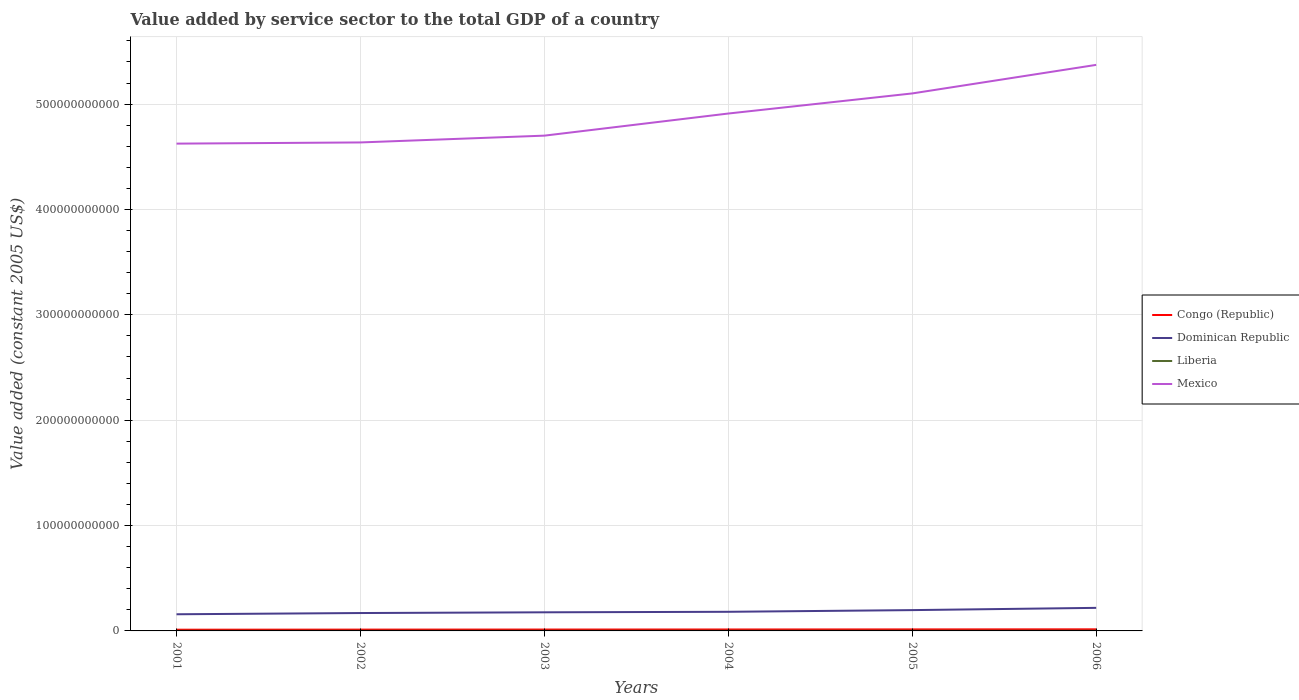Is the number of lines equal to the number of legend labels?
Offer a very short reply. Yes. Across all years, what is the maximum value added by service sector in Mexico?
Ensure brevity in your answer.  4.62e+11. In which year was the value added by service sector in Mexico maximum?
Give a very brief answer. 2001. What is the total value added by service sector in Liberia in the graph?
Your answer should be compact. -7.32e+06. What is the difference between the highest and the second highest value added by service sector in Mexico?
Ensure brevity in your answer.  7.47e+1. What is the difference between the highest and the lowest value added by service sector in Congo (Republic)?
Ensure brevity in your answer.  3. Is the value added by service sector in Congo (Republic) strictly greater than the value added by service sector in Mexico over the years?
Your answer should be compact. Yes. How many lines are there?
Keep it short and to the point. 4. What is the difference between two consecutive major ticks on the Y-axis?
Your response must be concise. 1.00e+11. Does the graph contain any zero values?
Offer a terse response. No. Does the graph contain grids?
Keep it short and to the point. Yes. Where does the legend appear in the graph?
Ensure brevity in your answer.  Center right. How many legend labels are there?
Provide a short and direct response. 4. How are the legend labels stacked?
Your answer should be compact. Vertical. What is the title of the graph?
Ensure brevity in your answer.  Value added by service sector to the total GDP of a country. What is the label or title of the X-axis?
Make the answer very short. Years. What is the label or title of the Y-axis?
Ensure brevity in your answer.  Value added (constant 2005 US$). What is the Value added (constant 2005 US$) of Congo (Republic) in 2001?
Make the answer very short. 1.16e+09. What is the Value added (constant 2005 US$) in Dominican Republic in 2001?
Give a very brief answer. 1.58e+1. What is the Value added (constant 2005 US$) in Liberia in 2001?
Your answer should be very brief. 1.06e+08. What is the Value added (constant 2005 US$) of Mexico in 2001?
Offer a terse response. 4.62e+11. What is the Value added (constant 2005 US$) of Congo (Republic) in 2002?
Keep it short and to the point. 1.25e+09. What is the Value added (constant 2005 US$) of Dominican Republic in 2002?
Ensure brevity in your answer.  1.70e+1. What is the Value added (constant 2005 US$) in Liberia in 2002?
Make the answer very short. 1.13e+08. What is the Value added (constant 2005 US$) of Mexico in 2002?
Ensure brevity in your answer.  4.64e+11. What is the Value added (constant 2005 US$) of Congo (Republic) in 2003?
Ensure brevity in your answer.  1.31e+09. What is the Value added (constant 2005 US$) of Dominican Republic in 2003?
Keep it short and to the point. 1.77e+1. What is the Value added (constant 2005 US$) in Liberia in 2003?
Your answer should be very brief. 1.11e+08. What is the Value added (constant 2005 US$) of Mexico in 2003?
Your answer should be compact. 4.70e+11. What is the Value added (constant 2005 US$) of Congo (Republic) in 2004?
Provide a short and direct response. 1.37e+09. What is the Value added (constant 2005 US$) in Dominican Republic in 2004?
Your answer should be compact. 1.81e+1. What is the Value added (constant 2005 US$) in Liberia in 2004?
Give a very brief answer. 1.35e+08. What is the Value added (constant 2005 US$) in Mexico in 2004?
Give a very brief answer. 4.91e+11. What is the Value added (constant 2005 US$) in Congo (Republic) in 2005?
Provide a short and direct response. 1.43e+09. What is the Value added (constant 2005 US$) in Dominican Republic in 2005?
Ensure brevity in your answer.  1.97e+1. What is the Value added (constant 2005 US$) in Liberia in 2005?
Your answer should be very brief. 1.47e+08. What is the Value added (constant 2005 US$) of Mexico in 2005?
Your answer should be compact. 5.10e+11. What is the Value added (constant 2005 US$) in Congo (Republic) in 2006?
Provide a short and direct response. 1.51e+09. What is the Value added (constant 2005 US$) in Dominican Republic in 2006?
Offer a very short reply. 2.19e+1. What is the Value added (constant 2005 US$) in Liberia in 2006?
Offer a terse response. 1.67e+08. What is the Value added (constant 2005 US$) in Mexico in 2006?
Make the answer very short. 5.37e+11. Across all years, what is the maximum Value added (constant 2005 US$) in Congo (Republic)?
Keep it short and to the point. 1.51e+09. Across all years, what is the maximum Value added (constant 2005 US$) of Dominican Republic?
Give a very brief answer. 2.19e+1. Across all years, what is the maximum Value added (constant 2005 US$) of Liberia?
Offer a very short reply. 1.67e+08. Across all years, what is the maximum Value added (constant 2005 US$) in Mexico?
Give a very brief answer. 5.37e+11. Across all years, what is the minimum Value added (constant 2005 US$) of Congo (Republic)?
Offer a terse response. 1.16e+09. Across all years, what is the minimum Value added (constant 2005 US$) of Dominican Republic?
Keep it short and to the point. 1.58e+1. Across all years, what is the minimum Value added (constant 2005 US$) of Liberia?
Make the answer very short. 1.06e+08. Across all years, what is the minimum Value added (constant 2005 US$) of Mexico?
Your response must be concise. 4.62e+11. What is the total Value added (constant 2005 US$) of Congo (Republic) in the graph?
Provide a short and direct response. 8.03e+09. What is the total Value added (constant 2005 US$) in Dominican Republic in the graph?
Ensure brevity in your answer.  1.10e+11. What is the total Value added (constant 2005 US$) in Liberia in the graph?
Your response must be concise. 7.80e+08. What is the total Value added (constant 2005 US$) in Mexico in the graph?
Keep it short and to the point. 2.93e+12. What is the difference between the Value added (constant 2005 US$) of Congo (Republic) in 2001 and that in 2002?
Provide a succinct answer. -8.60e+07. What is the difference between the Value added (constant 2005 US$) of Dominican Republic in 2001 and that in 2002?
Your answer should be very brief. -1.18e+09. What is the difference between the Value added (constant 2005 US$) of Liberia in 2001 and that in 2002?
Make the answer very short. -7.32e+06. What is the difference between the Value added (constant 2005 US$) in Mexico in 2001 and that in 2002?
Your response must be concise. -1.12e+09. What is the difference between the Value added (constant 2005 US$) in Congo (Republic) in 2001 and that in 2003?
Give a very brief answer. -1.43e+08. What is the difference between the Value added (constant 2005 US$) in Dominican Republic in 2001 and that in 2003?
Your answer should be very brief. -1.86e+09. What is the difference between the Value added (constant 2005 US$) of Liberia in 2001 and that in 2003?
Your response must be concise. -5.58e+06. What is the difference between the Value added (constant 2005 US$) of Mexico in 2001 and that in 2003?
Offer a terse response. -7.57e+09. What is the difference between the Value added (constant 2005 US$) of Congo (Republic) in 2001 and that in 2004?
Give a very brief answer. -2.03e+08. What is the difference between the Value added (constant 2005 US$) of Dominican Republic in 2001 and that in 2004?
Provide a succinct answer. -2.34e+09. What is the difference between the Value added (constant 2005 US$) of Liberia in 2001 and that in 2004?
Provide a succinct answer. -2.94e+07. What is the difference between the Value added (constant 2005 US$) of Mexico in 2001 and that in 2004?
Give a very brief answer. -2.86e+1. What is the difference between the Value added (constant 2005 US$) in Congo (Republic) in 2001 and that in 2005?
Give a very brief answer. -2.72e+08. What is the difference between the Value added (constant 2005 US$) of Dominican Republic in 2001 and that in 2005?
Make the answer very short. -3.94e+09. What is the difference between the Value added (constant 2005 US$) of Liberia in 2001 and that in 2005?
Your answer should be compact. -4.12e+07. What is the difference between the Value added (constant 2005 US$) in Mexico in 2001 and that in 2005?
Your answer should be compact. -4.76e+1. What is the difference between the Value added (constant 2005 US$) of Congo (Republic) in 2001 and that in 2006?
Ensure brevity in your answer.  -3.52e+08. What is the difference between the Value added (constant 2005 US$) of Dominican Republic in 2001 and that in 2006?
Offer a very short reply. -6.09e+09. What is the difference between the Value added (constant 2005 US$) in Liberia in 2001 and that in 2006?
Give a very brief answer. -6.15e+07. What is the difference between the Value added (constant 2005 US$) of Mexico in 2001 and that in 2006?
Keep it short and to the point. -7.47e+1. What is the difference between the Value added (constant 2005 US$) in Congo (Republic) in 2002 and that in 2003?
Provide a succinct answer. -5.72e+07. What is the difference between the Value added (constant 2005 US$) of Dominican Republic in 2002 and that in 2003?
Provide a succinct answer. -6.85e+08. What is the difference between the Value added (constant 2005 US$) of Liberia in 2002 and that in 2003?
Offer a terse response. 1.74e+06. What is the difference between the Value added (constant 2005 US$) in Mexico in 2002 and that in 2003?
Your answer should be compact. -6.45e+09. What is the difference between the Value added (constant 2005 US$) in Congo (Republic) in 2002 and that in 2004?
Keep it short and to the point. -1.17e+08. What is the difference between the Value added (constant 2005 US$) of Dominican Republic in 2002 and that in 2004?
Keep it short and to the point. -1.16e+09. What is the difference between the Value added (constant 2005 US$) in Liberia in 2002 and that in 2004?
Your response must be concise. -2.21e+07. What is the difference between the Value added (constant 2005 US$) in Mexico in 2002 and that in 2004?
Give a very brief answer. -2.74e+1. What is the difference between the Value added (constant 2005 US$) of Congo (Republic) in 2002 and that in 2005?
Offer a very short reply. -1.86e+08. What is the difference between the Value added (constant 2005 US$) of Dominican Republic in 2002 and that in 2005?
Give a very brief answer. -2.76e+09. What is the difference between the Value added (constant 2005 US$) in Liberia in 2002 and that in 2005?
Your answer should be compact. -3.39e+07. What is the difference between the Value added (constant 2005 US$) of Mexico in 2002 and that in 2005?
Offer a very short reply. -4.65e+1. What is the difference between the Value added (constant 2005 US$) in Congo (Republic) in 2002 and that in 2006?
Your answer should be very brief. -2.66e+08. What is the difference between the Value added (constant 2005 US$) of Dominican Republic in 2002 and that in 2006?
Your answer should be very brief. -4.91e+09. What is the difference between the Value added (constant 2005 US$) of Liberia in 2002 and that in 2006?
Give a very brief answer. -5.41e+07. What is the difference between the Value added (constant 2005 US$) in Mexico in 2002 and that in 2006?
Your answer should be compact. -7.36e+1. What is the difference between the Value added (constant 2005 US$) of Congo (Republic) in 2003 and that in 2004?
Make the answer very short. -6.02e+07. What is the difference between the Value added (constant 2005 US$) of Dominican Republic in 2003 and that in 2004?
Ensure brevity in your answer.  -4.76e+08. What is the difference between the Value added (constant 2005 US$) of Liberia in 2003 and that in 2004?
Your response must be concise. -2.39e+07. What is the difference between the Value added (constant 2005 US$) in Mexico in 2003 and that in 2004?
Offer a very short reply. -2.10e+1. What is the difference between the Value added (constant 2005 US$) of Congo (Republic) in 2003 and that in 2005?
Provide a short and direct response. -1.29e+08. What is the difference between the Value added (constant 2005 US$) in Dominican Republic in 2003 and that in 2005?
Give a very brief answer. -2.08e+09. What is the difference between the Value added (constant 2005 US$) in Liberia in 2003 and that in 2005?
Offer a very short reply. -3.57e+07. What is the difference between the Value added (constant 2005 US$) in Mexico in 2003 and that in 2005?
Offer a very short reply. -4.01e+1. What is the difference between the Value added (constant 2005 US$) of Congo (Republic) in 2003 and that in 2006?
Keep it short and to the point. -2.09e+08. What is the difference between the Value added (constant 2005 US$) of Dominican Republic in 2003 and that in 2006?
Offer a terse response. -4.22e+09. What is the difference between the Value added (constant 2005 US$) in Liberia in 2003 and that in 2006?
Your answer should be compact. -5.59e+07. What is the difference between the Value added (constant 2005 US$) of Mexico in 2003 and that in 2006?
Provide a succinct answer. -6.72e+1. What is the difference between the Value added (constant 2005 US$) of Congo (Republic) in 2004 and that in 2005?
Give a very brief answer. -6.90e+07. What is the difference between the Value added (constant 2005 US$) in Dominican Republic in 2004 and that in 2005?
Offer a terse response. -1.60e+09. What is the difference between the Value added (constant 2005 US$) in Liberia in 2004 and that in 2005?
Ensure brevity in your answer.  -1.18e+07. What is the difference between the Value added (constant 2005 US$) of Mexico in 2004 and that in 2005?
Give a very brief answer. -1.91e+1. What is the difference between the Value added (constant 2005 US$) of Congo (Republic) in 2004 and that in 2006?
Offer a terse response. -1.49e+08. What is the difference between the Value added (constant 2005 US$) in Dominican Republic in 2004 and that in 2006?
Make the answer very short. -3.75e+09. What is the difference between the Value added (constant 2005 US$) of Liberia in 2004 and that in 2006?
Keep it short and to the point. -3.20e+07. What is the difference between the Value added (constant 2005 US$) in Mexico in 2004 and that in 2006?
Your response must be concise. -4.62e+1. What is the difference between the Value added (constant 2005 US$) of Congo (Republic) in 2005 and that in 2006?
Ensure brevity in your answer.  -7.96e+07. What is the difference between the Value added (constant 2005 US$) of Dominican Republic in 2005 and that in 2006?
Ensure brevity in your answer.  -2.14e+09. What is the difference between the Value added (constant 2005 US$) of Liberia in 2005 and that in 2006?
Provide a succinct answer. -2.02e+07. What is the difference between the Value added (constant 2005 US$) of Mexico in 2005 and that in 2006?
Your answer should be compact. -2.71e+1. What is the difference between the Value added (constant 2005 US$) of Congo (Republic) in 2001 and the Value added (constant 2005 US$) of Dominican Republic in 2002?
Provide a succinct answer. -1.58e+1. What is the difference between the Value added (constant 2005 US$) in Congo (Republic) in 2001 and the Value added (constant 2005 US$) in Liberia in 2002?
Your answer should be compact. 1.05e+09. What is the difference between the Value added (constant 2005 US$) in Congo (Republic) in 2001 and the Value added (constant 2005 US$) in Mexico in 2002?
Offer a terse response. -4.62e+11. What is the difference between the Value added (constant 2005 US$) in Dominican Republic in 2001 and the Value added (constant 2005 US$) in Liberia in 2002?
Offer a very short reply. 1.57e+1. What is the difference between the Value added (constant 2005 US$) of Dominican Republic in 2001 and the Value added (constant 2005 US$) of Mexico in 2002?
Your answer should be very brief. -4.48e+11. What is the difference between the Value added (constant 2005 US$) of Liberia in 2001 and the Value added (constant 2005 US$) of Mexico in 2002?
Provide a short and direct response. -4.63e+11. What is the difference between the Value added (constant 2005 US$) of Congo (Republic) in 2001 and the Value added (constant 2005 US$) of Dominican Republic in 2003?
Your answer should be compact. -1.65e+1. What is the difference between the Value added (constant 2005 US$) of Congo (Republic) in 2001 and the Value added (constant 2005 US$) of Liberia in 2003?
Your response must be concise. 1.05e+09. What is the difference between the Value added (constant 2005 US$) in Congo (Republic) in 2001 and the Value added (constant 2005 US$) in Mexico in 2003?
Give a very brief answer. -4.69e+11. What is the difference between the Value added (constant 2005 US$) in Dominican Republic in 2001 and the Value added (constant 2005 US$) in Liberia in 2003?
Offer a terse response. 1.57e+1. What is the difference between the Value added (constant 2005 US$) of Dominican Republic in 2001 and the Value added (constant 2005 US$) of Mexico in 2003?
Provide a short and direct response. -4.54e+11. What is the difference between the Value added (constant 2005 US$) in Liberia in 2001 and the Value added (constant 2005 US$) in Mexico in 2003?
Provide a short and direct response. -4.70e+11. What is the difference between the Value added (constant 2005 US$) of Congo (Republic) in 2001 and the Value added (constant 2005 US$) of Dominican Republic in 2004?
Your response must be concise. -1.70e+1. What is the difference between the Value added (constant 2005 US$) of Congo (Republic) in 2001 and the Value added (constant 2005 US$) of Liberia in 2004?
Provide a succinct answer. 1.03e+09. What is the difference between the Value added (constant 2005 US$) in Congo (Republic) in 2001 and the Value added (constant 2005 US$) in Mexico in 2004?
Make the answer very short. -4.90e+11. What is the difference between the Value added (constant 2005 US$) of Dominican Republic in 2001 and the Value added (constant 2005 US$) of Liberia in 2004?
Your response must be concise. 1.57e+1. What is the difference between the Value added (constant 2005 US$) in Dominican Republic in 2001 and the Value added (constant 2005 US$) in Mexico in 2004?
Offer a terse response. -4.75e+11. What is the difference between the Value added (constant 2005 US$) of Liberia in 2001 and the Value added (constant 2005 US$) of Mexico in 2004?
Make the answer very short. -4.91e+11. What is the difference between the Value added (constant 2005 US$) of Congo (Republic) in 2001 and the Value added (constant 2005 US$) of Dominican Republic in 2005?
Ensure brevity in your answer.  -1.86e+1. What is the difference between the Value added (constant 2005 US$) in Congo (Republic) in 2001 and the Value added (constant 2005 US$) in Liberia in 2005?
Provide a succinct answer. 1.02e+09. What is the difference between the Value added (constant 2005 US$) of Congo (Republic) in 2001 and the Value added (constant 2005 US$) of Mexico in 2005?
Your answer should be compact. -5.09e+11. What is the difference between the Value added (constant 2005 US$) in Dominican Republic in 2001 and the Value added (constant 2005 US$) in Liberia in 2005?
Your answer should be very brief. 1.57e+1. What is the difference between the Value added (constant 2005 US$) in Dominican Republic in 2001 and the Value added (constant 2005 US$) in Mexico in 2005?
Offer a terse response. -4.94e+11. What is the difference between the Value added (constant 2005 US$) in Liberia in 2001 and the Value added (constant 2005 US$) in Mexico in 2005?
Ensure brevity in your answer.  -5.10e+11. What is the difference between the Value added (constant 2005 US$) of Congo (Republic) in 2001 and the Value added (constant 2005 US$) of Dominican Republic in 2006?
Give a very brief answer. -2.07e+1. What is the difference between the Value added (constant 2005 US$) in Congo (Republic) in 2001 and the Value added (constant 2005 US$) in Liberia in 2006?
Make the answer very short. 9.95e+08. What is the difference between the Value added (constant 2005 US$) in Congo (Republic) in 2001 and the Value added (constant 2005 US$) in Mexico in 2006?
Your answer should be compact. -5.36e+11. What is the difference between the Value added (constant 2005 US$) of Dominican Republic in 2001 and the Value added (constant 2005 US$) of Liberia in 2006?
Ensure brevity in your answer.  1.56e+1. What is the difference between the Value added (constant 2005 US$) in Dominican Republic in 2001 and the Value added (constant 2005 US$) in Mexico in 2006?
Give a very brief answer. -5.21e+11. What is the difference between the Value added (constant 2005 US$) in Liberia in 2001 and the Value added (constant 2005 US$) in Mexico in 2006?
Provide a short and direct response. -5.37e+11. What is the difference between the Value added (constant 2005 US$) of Congo (Republic) in 2002 and the Value added (constant 2005 US$) of Dominican Republic in 2003?
Your answer should be compact. -1.64e+1. What is the difference between the Value added (constant 2005 US$) in Congo (Republic) in 2002 and the Value added (constant 2005 US$) in Liberia in 2003?
Offer a very short reply. 1.14e+09. What is the difference between the Value added (constant 2005 US$) of Congo (Republic) in 2002 and the Value added (constant 2005 US$) of Mexico in 2003?
Provide a succinct answer. -4.69e+11. What is the difference between the Value added (constant 2005 US$) of Dominican Republic in 2002 and the Value added (constant 2005 US$) of Liberia in 2003?
Your response must be concise. 1.69e+1. What is the difference between the Value added (constant 2005 US$) in Dominican Republic in 2002 and the Value added (constant 2005 US$) in Mexico in 2003?
Provide a succinct answer. -4.53e+11. What is the difference between the Value added (constant 2005 US$) of Liberia in 2002 and the Value added (constant 2005 US$) of Mexico in 2003?
Give a very brief answer. -4.70e+11. What is the difference between the Value added (constant 2005 US$) in Congo (Republic) in 2002 and the Value added (constant 2005 US$) in Dominican Republic in 2004?
Keep it short and to the point. -1.69e+1. What is the difference between the Value added (constant 2005 US$) of Congo (Republic) in 2002 and the Value added (constant 2005 US$) of Liberia in 2004?
Offer a terse response. 1.11e+09. What is the difference between the Value added (constant 2005 US$) in Congo (Republic) in 2002 and the Value added (constant 2005 US$) in Mexico in 2004?
Your response must be concise. -4.90e+11. What is the difference between the Value added (constant 2005 US$) of Dominican Republic in 2002 and the Value added (constant 2005 US$) of Liberia in 2004?
Offer a terse response. 1.68e+1. What is the difference between the Value added (constant 2005 US$) of Dominican Republic in 2002 and the Value added (constant 2005 US$) of Mexico in 2004?
Keep it short and to the point. -4.74e+11. What is the difference between the Value added (constant 2005 US$) of Liberia in 2002 and the Value added (constant 2005 US$) of Mexico in 2004?
Your response must be concise. -4.91e+11. What is the difference between the Value added (constant 2005 US$) of Congo (Republic) in 2002 and the Value added (constant 2005 US$) of Dominican Republic in 2005?
Ensure brevity in your answer.  -1.85e+1. What is the difference between the Value added (constant 2005 US$) in Congo (Republic) in 2002 and the Value added (constant 2005 US$) in Liberia in 2005?
Your answer should be compact. 1.10e+09. What is the difference between the Value added (constant 2005 US$) of Congo (Republic) in 2002 and the Value added (constant 2005 US$) of Mexico in 2005?
Keep it short and to the point. -5.09e+11. What is the difference between the Value added (constant 2005 US$) of Dominican Republic in 2002 and the Value added (constant 2005 US$) of Liberia in 2005?
Make the answer very short. 1.68e+1. What is the difference between the Value added (constant 2005 US$) in Dominican Republic in 2002 and the Value added (constant 2005 US$) in Mexico in 2005?
Provide a short and direct response. -4.93e+11. What is the difference between the Value added (constant 2005 US$) of Liberia in 2002 and the Value added (constant 2005 US$) of Mexico in 2005?
Provide a short and direct response. -5.10e+11. What is the difference between the Value added (constant 2005 US$) of Congo (Republic) in 2002 and the Value added (constant 2005 US$) of Dominican Republic in 2006?
Ensure brevity in your answer.  -2.06e+1. What is the difference between the Value added (constant 2005 US$) in Congo (Republic) in 2002 and the Value added (constant 2005 US$) in Liberia in 2006?
Keep it short and to the point. 1.08e+09. What is the difference between the Value added (constant 2005 US$) in Congo (Republic) in 2002 and the Value added (constant 2005 US$) in Mexico in 2006?
Give a very brief answer. -5.36e+11. What is the difference between the Value added (constant 2005 US$) in Dominican Republic in 2002 and the Value added (constant 2005 US$) in Liberia in 2006?
Ensure brevity in your answer.  1.68e+1. What is the difference between the Value added (constant 2005 US$) in Dominican Republic in 2002 and the Value added (constant 2005 US$) in Mexico in 2006?
Your answer should be compact. -5.20e+11. What is the difference between the Value added (constant 2005 US$) of Liberia in 2002 and the Value added (constant 2005 US$) of Mexico in 2006?
Offer a very short reply. -5.37e+11. What is the difference between the Value added (constant 2005 US$) in Congo (Republic) in 2003 and the Value added (constant 2005 US$) in Dominican Republic in 2004?
Provide a succinct answer. -1.68e+1. What is the difference between the Value added (constant 2005 US$) in Congo (Republic) in 2003 and the Value added (constant 2005 US$) in Liberia in 2004?
Provide a short and direct response. 1.17e+09. What is the difference between the Value added (constant 2005 US$) in Congo (Republic) in 2003 and the Value added (constant 2005 US$) in Mexico in 2004?
Provide a succinct answer. -4.90e+11. What is the difference between the Value added (constant 2005 US$) in Dominican Republic in 2003 and the Value added (constant 2005 US$) in Liberia in 2004?
Offer a very short reply. 1.75e+1. What is the difference between the Value added (constant 2005 US$) of Dominican Republic in 2003 and the Value added (constant 2005 US$) of Mexico in 2004?
Your response must be concise. -4.73e+11. What is the difference between the Value added (constant 2005 US$) in Liberia in 2003 and the Value added (constant 2005 US$) in Mexico in 2004?
Ensure brevity in your answer.  -4.91e+11. What is the difference between the Value added (constant 2005 US$) in Congo (Republic) in 2003 and the Value added (constant 2005 US$) in Dominican Republic in 2005?
Your answer should be compact. -1.84e+1. What is the difference between the Value added (constant 2005 US$) of Congo (Republic) in 2003 and the Value added (constant 2005 US$) of Liberia in 2005?
Provide a short and direct response. 1.16e+09. What is the difference between the Value added (constant 2005 US$) of Congo (Republic) in 2003 and the Value added (constant 2005 US$) of Mexico in 2005?
Your answer should be very brief. -5.09e+11. What is the difference between the Value added (constant 2005 US$) in Dominican Republic in 2003 and the Value added (constant 2005 US$) in Liberia in 2005?
Give a very brief answer. 1.75e+1. What is the difference between the Value added (constant 2005 US$) in Dominican Republic in 2003 and the Value added (constant 2005 US$) in Mexico in 2005?
Give a very brief answer. -4.92e+11. What is the difference between the Value added (constant 2005 US$) of Liberia in 2003 and the Value added (constant 2005 US$) of Mexico in 2005?
Make the answer very short. -5.10e+11. What is the difference between the Value added (constant 2005 US$) in Congo (Republic) in 2003 and the Value added (constant 2005 US$) in Dominican Republic in 2006?
Offer a terse response. -2.06e+1. What is the difference between the Value added (constant 2005 US$) in Congo (Republic) in 2003 and the Value added (constant 2005 US$) in Liberia in 2006?
Give a very brief answer. 1.14e+09. What is the difference between the Value added (constant 2005 US$) of Congo (Republic) in 2003 and the Value added (constant 2005 US$) of Mexico in 2006?
Ensure brevity in your answer.  -5.36e+11. What is the difference between the Value added (constant 2005 US$) of Dominican Republic in 2003 and the Value added (constant 2005 US$) of Liberia in 2006?
Make the answer very short. 1.75e+1. What is the difference between the Value added (constant 2005 US$) of Dominican Republic in 2003 and the Value added (constant 2005 US$) of Mexico in 2006?
Offer a terse response. -5.20e+11. What is the difference between the Value added (constant 2005 US$) in Liberia in 2003 and the Value added (constant 2005 US$) in Mexico in 2006?
Your answer should be compact. -5.37e+11. What is the difference between the Value added (constant 2005 US$) in Congo (Republic) in 2004 and the Value added (constant 2005 US$) in Dominican Republic in 2005?
Offer a very short reply. -1.84e+1. What is the difference between the Value added (constant 2005 US$) of Congo (Republic) in 2004 and the Value added (constant 2005 US$) of Liberia in 2005?
Your answer should be very brief. 1.22e+09. What is the difference between the Value added (constant 2005 US$) in Congo (Republic) in 2004 and the Value added (constant 2005 US$) in Mexico in 2005?
Offer a terse response. -5.09e+11. What is the difference between the Value added (constant 2005 US$) of Dominican Republic in 2004 and the Value added (constant 2005 US$) of Liberia in 2005?
Offer a very short reply. 1.80e+1. What is the difference between the Value added (constant 2005 US$) of Dominican Republic in 2004 and the Value added (constant 2005 US$) of Mexico in 2005?
Make the answer very short. -4.92e+11. What is the difference between the Value added (constant 2005 US$) in Liberia in 2004 and the Value added (constant 2005 US$) in Mexico in 2005?
Offer a terse response. -5.10e+11. What is the difference between the Value added (constant 2005 US$) in Congo (Republic) in 2004 and the Value added (constant 2005 US$) in Dominican Republic in 2006?
Provide a short and direct response. -2.05e+1. What is the difference between the Value added (constant 2005 US$) of Congo (Republic) in 2004 and the Value added (constant 2005 US$) of Liberia in 2006?
Ensure brevity in your answer.  1.20e+09. What is the difference between the Value added (constant 2005 US$) of Congo (Republic) in 2004 and the Value added (constant 2005 US$) of Mexico in 2006?
Offer a terse response. -5.36e+11. What is the difference between the Value added (constant 2005 US$) of Dominican Republic in 2004 and the Value added (constant 2005 US$) of Liberia in 2006?
Keep it short and to the point. 1.80e+1. What is the difference between the Value added (constant 2005 US$) of Dominican Republic in 2004 and the Value added (constant 2005 US$) of Mexico in 2006?
Offer a terse response. -5.19e+11. What is the difference between the Value added (constant 2005 US$) in Liberia in 2004 and the Value added (constant 2005 US$) in Mexico in 2006?
Provide a succinct answer. -5.37e+11. What is the difference between the Value added (constant 2005 US$) of Congo (Republic) in 2005 and the Value added (constant 2005 US$) of Dominican Republic in 2006?
Your answer should be very brief. -2.05e+1. What is the difference between the Value added (constant 2005 US$) in Congo (Republic) in 2005 and the Value added (constant 2005 US$) in Liberia in 2006?
Make the answer very short. 1.27e+09. What is the difference between the Value added (constant 2005 US$) of Congo (Republic) in 2005 and the Value added (constant 2005 US$) of Mexico in 2006?
Your answer should be very brief. -5.36e+11. What is the difference between the Value added (constant 2005 US$) in Dominican Republic in 2005 and the Value added (constant 2005 US$) in Liberia in 2006?
Provide a short and direct response. 1.96e+1. What is the difference between the Value added (constant 2005 US$) of Dominican Republic in 2005 and the Value added (constant 2005 US$) of Mexico in 2006?
Your response must be concise. -5.17e+11. What is the difference between the Value added (constant 2005 US$) of Liberia in 2005 and the Value added (constant 2005 US$) of Mexico in 2006?
Keep it short and to the point. -5.37e+11. What is the average Value added (constant 2005 US$) of Congo (Republic) per year?
Offer a very short reply. 1.34e+09. What is the average Value added (constant 2005 US$) of Dominican Republic per year?
Ensure brevity in your answer.  1.84e+1. What is the average Value added (constant 2005 US$) in Liberia per year?
Offer a terse response. 1.30e+08. What is the average Value added (constant 2005 US$) in Mexico per year?
Offer a very short reply. 4.89e+11. In the year 2001, what is the difference between the Value added (constant 2005 US$) of Congo (Republic) and Value added (constant 2005 US$) of Dominican Republic?
Provide a succinct answer. -1.46e+1. In the year 2001, what is the difference between the Value added (constant 2005 US$) of Congo (Republic) and Value added (constant 2005 US$) of Liberia?
Your response must be concise. 1.06e+09. In the year 2001, what is the difference between the Value added (constant 2005 US$) in Congo (Republic) and Value added (constant 2005 US$) in Mexico?
Keep it short and to the point. -4.61e+11. In the year 2001, what is the difference between the Value added (constant 2005 US$) in Dominican Republic and Value added (constant 2005 US$) in Liberia?
Keep it short and to the point. 1.57e+1. In the year 2001, what is the difference between the Value added (constant 2005 US$) in Dominican Republic and Value added (constant 2005 US$) in Mexico?
Your answer should be compact. -4.47e+11. In the year 2001, what is the difference between the Value added (constant 2005 US$) in Liberia and Value added (constant 2005 US$) in Mexico?
Offer a terse response. -4.62e+11. In the year 2002, what is the difference between the Value added (constant 2005 US$) in Congo (Republic) and Value added (constant 2005 US$) in Dominican Republic?
Your answer should be compact. -1.57e+1. In the year 2002, what is the difference between the Value added (constant 2005 US$) of Congo (Republic) and Value added (constant 2005 US$) of Liberia?
Your answer should be very brief. 1.14e+09. In the year 2002, what is the difference between the Value added (constant 2005 US$) in Congo (Republic) and Value added (constant 2005 US$) in Mexico?
Make the answer very short. -4.62e+11. In the year 2002, what is the difference between the Value added (constant 2005 US$) of Dominican Republic and Value added (constant 2005 US$) of Liberia?
Your answer should be very brief. 1.69e+1. In the year 2002, what is the difference between the Value added (constant 2005 US$) in Dominican Republic and Value added (constant 2005 US$) in Mexico?
Your response must be concise. -4.47e+11. In the year 2002, what is the difference between the Value added (constant 2005 US$) in Liberia and Value added (constant 2005 US$) in Mexico?
Provide a succinct answer. -4.63e+11. In the year 2003, what is the difference between the Value added (constant 2005 US$) in Congo (Republic) and Value added (constant 2005 US$) in Dominican Republic?
Your answer should be compact. -1.64e+1. In the year 2003, what is the difference between the Value added (constant 2005 US$) in Congo (Republic) and Value added (constant 2005 US$) in Liberia?
Offer a terse response. 1.19e+09. In the year 2003, what is the difference between the Value added (constant 2005 US$) in Congo (Republic) and Value added (constant 2005 US$) in Mexico?
Your response must be concise. -4.69e+11. In the year 2003, what is the difference between the Value added (constant 2005 US$) of Dominican Republic and Value added (constant 2005 US$) of Liberia?
Your answer should be compact. 1.76e+1. In the year 2003, what is the difference between the Value added (constant 2005 US$) in Dominican Republic and Value added (constant 2005 US$) in Mexico?
Provide a short and direct response. -4.52e+11. In the year 2003, what is the difference between the Value added (constant 2005 US$) of Liberia and Value added (constant 2005 US$) of Mexico?
Ensure brevity in your answer.  -4.70e+11. In the year 2004, what is the difference between the Value added (constant 2005 US$) of Congo (Republic) and Value added (constant 2005 US$) of Dominican Republic?
Make the answer very short. -1.68e+1. In the year 2004, what is the difference between the Value added (constant 2005 US$) in Congo (Republic) and Value added (constant 2005 US$) in Liberia?
Your response must be concise. 1.23e+09. In the year 2004, what is the difference between the Value added (constant 2005 US$) of Congo (Republic) and Value added (constant 2005 US$) of Mexico?
Your answer should be very brief. -4.90e+11. In the year 2004, what is the difference between the Value added (constant 2005 US$) in Dominican Republic and Value added (constant 2005 US$) in Liberia?
Offer a terse response. 1.80e+1. In the year 2004, what is the difference between the Value added (constant 2005 US$) of Dominican Republic and Value added (constant 2005 US$) of Mexico?
Provide a short and direct response. -4.73e+11. In the year 2004, what is the difference between the Value added (constant 2005 US$) in Liberia and Value added (constant 2005 US$) in Mexico?
Your answer should be compact. -4.91e+11. In the year 2005, what is the difference between the Value added (constant 2005 US$) in Congo (Republic) and Value added (constant 2005 US$) in Dominican Republic?
Offer a terse response. -1.83e+1. In the year 2005, what is the difference between the Value added (constant 2005 US$) of Congo (Republic) and Value added (constant 2005 US$) of Liberia?
Your answer should be compact. 1.29e+09. In the year 2005, what is the difference between the Value added (constant 2005 US$) in Congo (Republic) and Value added (constant 2005 US$) in Mexico?
Provide a succinct answer. -5.09e+11. In the year 2005, what is the difference between the Value added (constant 2005 US$) of Dominican Republic and Value added (constant 2005 US$) of Liberia?
Keep it short and to the point. 1.96e+1. In the year 2005, what is the difference between the Value added (constant 2005 US$) of Dominican Republic and Value added (constant 2005 US$) of Mexico?
Make the answer very short. -4.90e+11. In the year 2005, what is the difference between the Value added (constant 2005 US$) of Liberia and Value added (constant 2005 US$) of Mexico?
Keep it short and to the point. -5.10e+11. In the year 2006, what is the difference between the Value added (constant 2005 US$) in Congo (Republic) and Value added (constant 2005 US$) in Dominican Republic?
Provide a succinct answer. -2.04e+1. In the year 2006, what is the difference between the Value added (constant 2005 US$) in Congo (Republic) and Value added (constant 2005 US$) in Liberia?
Make the answer very short. 1.35e+09. In the year 2006, what is the difference between the Value added (constant 2005 US$) in Congo (Republic) and Value added (constant 2005 US$) in Mexico?
Ensure brevity in your answer.  -5.36e+11. In the year 2006, what is the difference between the Value added (constant 2005 US$) of Dominican Republic and Value added (constant 2005 US$) of Liberia?
Your response must be concise. 2.17e+1. In the year 2006, what is the difference between the Value added (constant 2005 US$) in Dominican Republic and Value added (constant 2005 US$) in Mexico?
Provide a short and direct response. -5.15e+11. In the year 2006, what is the difference between the Value added (constant 2005 US$) of Liberia and Value added (constant 2005 US$) of Mexico?
Keep it short and to the point. -5.37e+11. What is the ratio of the Value added (constant 2005 US$) in Congo (Republic) in 2001 to that in 2002?
Offer a very short reply. 0.93. What is the ratio of the Value added (constant 2005 US$) of Dominican Republic in 2001 to that in 2002?
Your answer should be very brief. 0.93. What is the ratio of the Value added (constant 2005 US$) in Liberia in 2001 to that in 2002?
Provide a short and direct response. 0.94. What is the ratio of the Value added (constant 2005 US$) of Mexico in 2001 to that in 2002?
Offer a terse response. 1. What is the ratio of the Value added (constant 2005 US$) of Congo (Republic) in 2001 to that in 2003?
Offer a very short reply. 0.89. What is the ratio of the Value added (constant 2005 US$) in Dominican Republic in 2001 to that in 2003?
Keep it short and to the point. 0.89. What is the ratio of the Value added (constant 2005 US$) of Liberia in 2001 to that in 2003?
Make the answer very short. 0.95. What is the ratio of the Value added (constant 2005 US$) of Mexico in 2001 to that in 2003?
Offer a very short reply. 0.98. What is the ratio of the Value added (constant 2005 US$) in Congo (Republic) in 2001 to that in 2004?
Offer a terse response. 0.85. What is the ratio of the Value added (constant 2005 US$) in Dominican Republic in 2001 to that in 2004?
Offer a very short reply. 0.87. What is the ratio of the Value added (constant 2005 US$) in Liberia in 2001 to that in 2004?
Provide a succinct answer. 0.78. What is the ratio of the Value added (constant 2005 US$) of Mexico in 2001 to that in 2004?
Make the answer very short. 0.94. What is the ratio of the Value added (constant 2005 US$) in Congo (Republic) in 2001 to that in 2005?
Your response must be concise. 0.81. What is the ratio of the Value added (constant 2005 US$) in Dominican Republic in 2001 to that in 2005?
Ensure brevity in your answer.  0.8. What is the ratio of the Value added (constant 2005 US$) in Liberia in 2001 to that in 2005?
Ensure brevity in your answer.  0.72. What is the ratio of the Value added (constant 2005 US$) in Mexico in 2001 to that in 2005?
Your answer should be very brief. 0.91. What is the ratio of the Value added (constant 2005 US$) of Congo (Republic) in 2001 to that in 2006?
Ensure brevity in your answer.  0.77. What is the ratio of the Value added (constant 2005 US$) of Dominican Republic in 2001 to that in 2006?
Offer a terse response. 0.72. What is the ratio of the Value added (constant 2005 US$) in Liberia in 2001 to that in 2006?
Your answer should be very brief. 0.63. What is the ratio of the Value added (constant 2005 US$) of Mexico in 2001 to that in 2006?
Make the answer very short. 0.86. What is the ratio of the Value added (constant 2005 US$) in Congo (Republic) in 2002 to that in 2003?
Offer a terse response. 0.96. What is the ratio of the Value added (constant 2005 US$) in Dominican Republic in 2002 to that in 2003?
Provide a short and direct response. 0.96. What is the ratio of the Value added (constant 2005 US$) in Liberia in 2002 to that in 2003?
Provide a succinct answer. 1.02. What is the ratio of the Value added (constant 2005 US$) of Mexico in 2002 to that in 2003?
Offer a very short reply. 0.99. What is the ratio of the Value added (constant 2005 US$) of Congo (Republic) in 2002 to that in 2004?
Provide a succinct answer. 0.91. What is the ratio of the Value added (constant 2005 US$) in Dominican Republic in 2002 to that in 2004?
Give a very brief answer. 0.94. What is the ratio of the Value added (constant 2005 US$) in Liberia in 2002 to that in 2004?
Your response must be concise. 0.84. What is the ratio of the Value added (constant 2005 US$) in Mexico in 2002 to that in 2004?
Provide a succinct answer. 0.94. What is the ratio of the Value added (constant 2005 US$) of Congo (Republic) in 2002 to that in 2005?
Keep it short and to the point. 0.87. What is the ratio of the Value added (constant 2005 US$) in Dominican Republic in 2002 to that in 2005?
Offer a terse response. 0.86. What is the ratio of the Value added (constant 2005 US$) of Liberia in 2002 to that in 2005?
Give a very brief answer. 0.77. What is the ratio of the Value added (constant 2005 US$) of Mexico in 2002 to that in 2005?
Provide a short and direct response. 0.91. What is the ratio of the Value added (constant 2005 US$) in Congo (Republic) in 2002 to that in 2006?
Ensure brevity in your answer.  0.82. What is the ratio of the Value added (constant 2005 US$) in Dominican Republic in 2002 to that in 2006?
Provide a short and direct response. 0.78. What is the ratio of the Value added (constant 2005 US$) of Liberia in 2002 to that in 2006?
Keep it short and to the point. 0.68. What is the ratio of the Value added (constant 2005 US$) in Mexico in 2002 to that in 2006?
Your response must be concise. 0.86. What is the ratio of the Value added (constant 2005 US$) in Congo (Republic) in 2003 to that in 2004?
Your response must be concise. 0.96. What is the ratio of the Value added (constant 2005 US$) of Dominican Republic in 2003 to that in 2004?
Your response must be concise. 0.97. What is the ratio of the Value added (constant 2005 US$) of Liberia in 2003 to that in 2004?
Your answer should be very brief. 0.82. What is the ratio of the Value added (constant 2005 US$) in Mexico in 2003 to that in 2004?
Your answer should be compact. 0.96. What is the ratio of the Value added (constant 2005 US$) of Congo (Republic) in 2003 to that in 2005?
Your answer should be very brief. 0.91. What is the ratio of the Value added (constant 2005 US$) in Dominican Republic in 2003 to that in 2005?
Your answer should be compact. 0.89. What is the ratio of the Value added (constant 2005 US$) in Liberia in 2003 to that in 2005?
Provide a short and direct response. 0.76. What is the ratio of the Value added (constant 2005 US$) in Mexico in 2003 to that in 2005?
Keep it short and to the point. 0.92. What is the ratio of the Value added (constant 2005 US$) of Congo (Republic) in 2003 to that in 2006?
Ensure brevity in your answer.  0.86. What is the ratio of the Value added (constant 2005 US$) in Dominican Republic in 2003 to that in 2006?
Offer a very short reply. 0.81. What is the ratio of the Value added (constant 2005 US$) of Liberia in 2003 to that in 2006?
Keep it short and to the point. 0.67. What is the ratio of the Value added (constant 2005 US$) of Mexico in 2003 to that in 2006?
Your answer should be very brief. 0.88. What is the ratio of the Value added (constant 2005 US$) in Congo (Republic) in 2004 to that in 2005?
Your answer should be very brief. 0.95. What is the ratio of the Value added (constant 2005 US$) in Dominican Republic in 2004 to that in 2005?
Give a very brief answer. 0.92. What is the ratio of the Value added (constant 2005 US$) of Liberia in 2004 to that in 2005?
Offer a terse response. 0.92. What is the ratio of the Value added (constant 2005 US$) in Mexico in 2004 to that in 2005?
Give a very brief answer. 0.96. What is the ratio of the Value added (constant 2005 US$) in Congo (Republic) in 2004 to that in 2006?
Your answer should be compact. 0.9. What is the ratio of the Value added (constant 2005 US$) in Dominican Republic in 2004 to that in 2006?
Provide a short and direct response. 0.83. What is the ratio of the Value added (constant 2005 US$) of Liberia in 2004 to that in 2006?
Give a very brief answer. 0.81. What is the ratio of the Value added (constant 2005 US$) of Mexico in 2004 to that in 2006?
Your answer should be very brief. 0.91. What is the ratio of the Value added (constant 2005 US$) in Congo (Republic) in 2005 to that in 2006?
Provide a succinct answer. 0.95. What is the ratio of the Value added (constant 2005 US$) of Dominican Republic in 2005 to that in 2006?
Provide a succinct answer. 0.9. What is the ratio of the Value added (constant 2005 US$) in Liberia in 2005 to that in 2006?
Your response must be concise. 0.88. What is the ratio of the Value added (constant 2005 US$) of Mexico in 2005 to that in 2006?
Your answer should be compact. 0.95. What is the difference between the highest and the second highest Value added (constant 2005 US$) in Congo (Republic)?
Make the answer very short. 7.96e+07. What is the difference between the highest and the second highest Value added (constant 2005 US$) of Dominican Republic?
Offer a terse response. 2.14e+09. What is the difference between the highest and the second highest Value added (constant 2005 US$) in Liberia?
Offer a terse response. 2.02e+07. What is the difference between the highest and the second highest Value added (constant 2005 US$) in Mexico?
Give a very brief answer. 2.71e+1. What is the difference between the highest and the lowest Value added (constant 2005 US$) in Congo (Republic)?
Your answer should be very brief. 3.52e+08. What is the difference between the highest and the lowest Value added (constant 2005 US$) of Dominican Republic?
Provide a succinct answer. 6.09e+09. What is the difference between the highest and the lowest Value added (constant 2005 US$) in Liberia?
Offer a very short reply. 6.15e+07. What is the difference between the highest and the lowest Value added (constant 2005 US$) in Mexico?
Offer a terse response. 7.47e+1. 